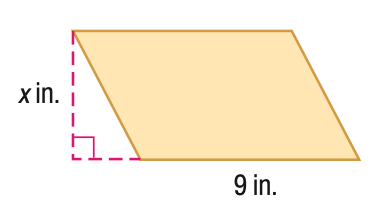Question: Find x. A = 153 in^2.
Choices:
A. 15
B. 17
C. 19
D. 21
Answer with the letter. Answer: B 